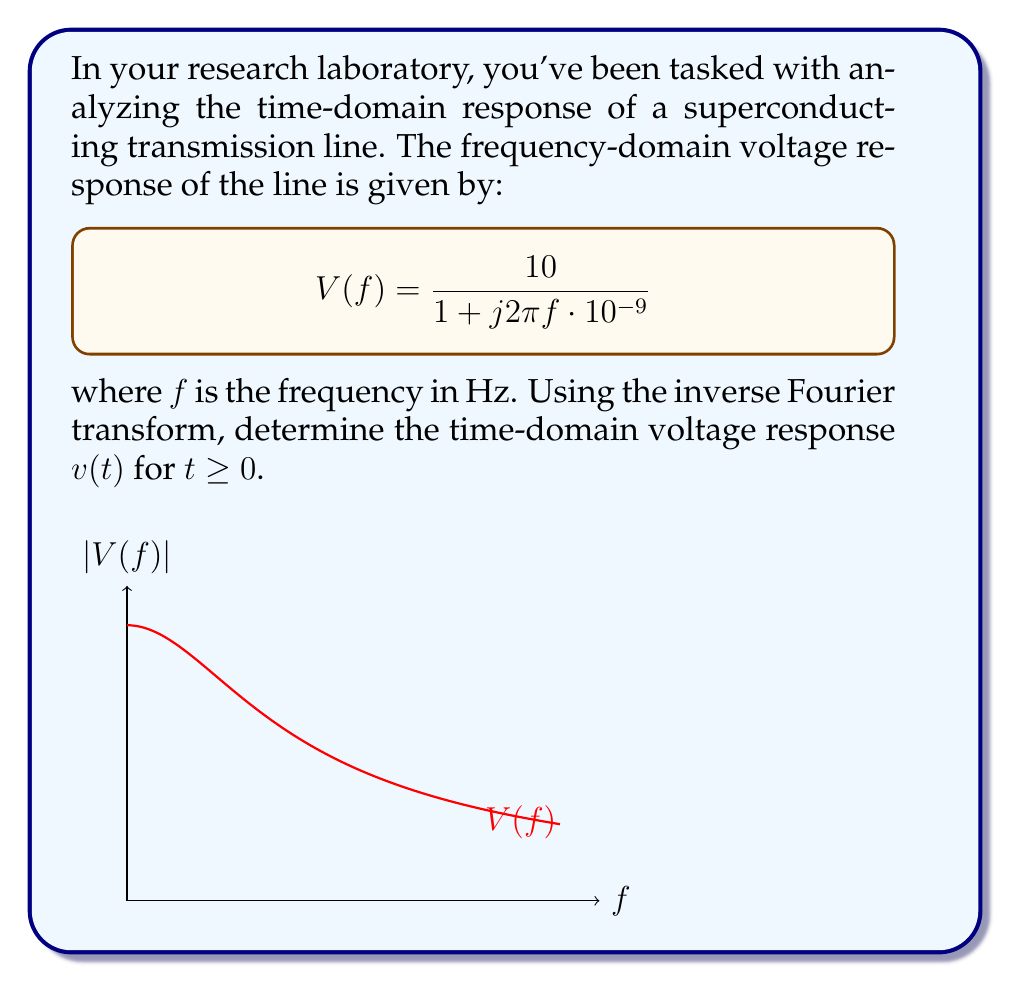Teach me how to tackle this problem. To find the time-domain response, we need to apply the inverse Fourier transform to $V(f)$. Let's approach this step-by-step:

1) The general form of the inverse Fourier transform is:

   $$v(t) = \int_{-\infty}^{\infty} V(f) e^{j2\pi ft} df$$

2) Our $V(f)$ can be rewritten as:

   $$V(f) = \frac{10}{1 + j2\pi f \cdot 10^{-9}} = \frac{10}{1 + j\omega \tau}$$

   where $\omega = 2\pi f$ and $\tau = 10^{-9}$ seconds.

3) This form is recognizable as the Fourier transform of an exponential decay. The inverse Fourier transform of $\frac{1}{1 + j\omega \tau}$ is $\frac{1}{\tau}e^{-t/\tau}u(t)$, where $u(t)$ is the unit step function.

4) Therefore, the time-domain response will be:

   $$v(t) = 10 \cdot \frac{1}{\tau}e^{-t/\tau}u(t)$$

5) Substituting $\tau = 10^{-9}$ seconds:

   $$v(t) = 10 \cdot 10^9 e^{-t/10^{-9}}u(t)$$

6) Simplifying:

   $$v(t) = 10^{10} e^{-10^9t}u(t)$$

This represents an exponential decay starting at $t=0$ with an initial value of $10^{10}$ volts and a time constant of $10^{-9}$ seconds.
Answer: $v(t) = 10^{10} e^{-10^9t}u(t)$ V 